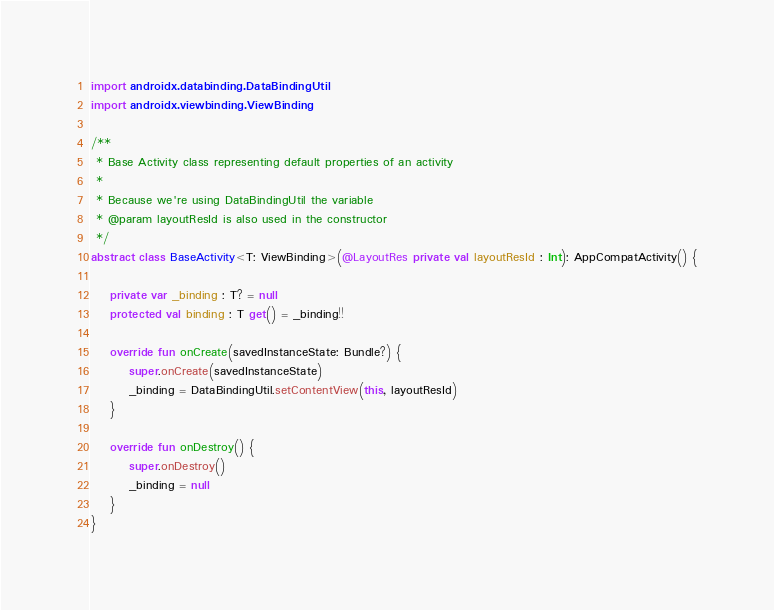<code> <loc_0><loc_0><loc_500><loc_500><_Kotlin_>import androidx.databinding.DataBindingUtil
import androidx.viewbinding.ViewBinding

/**
 * Base Activity class representing default properties of an activity
 *
 * Because we're using DataBindingUtil the variable
 * @param layoutResId is also used in the constructor
 */
abstract class BaseActivity<T: ViewBinding>(@LayoutRes private val layoutResId : Int): AppCompatActivity() {

    private var _binding : T? = null
    protected val binding : T get() = _binding!!

    override fun onCreate(savedInstanceState: Bundle?) {
        super.onCreate(savedInstanceState)
        _binding = DataBindingUtil.setContentView(this, layoutResId)
    }

    override fun onDestroy() {
        super.onDestroy()
        _binding = null
    }
}</code> 